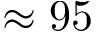Convert formula to latex. <formula><loc_0><loc_0><loc_500><loc_500>\approx 9 5</formula> 